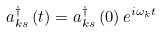<formula> <loc_0><loc_0><loc_500><loc_500>a _ { k s } ^ { \dagger } \left ( t \right ) = a _ { k s } ^ { \dagger } \left ( 0 \right ) e ^ { i \omega _ { k } t }</formula> 